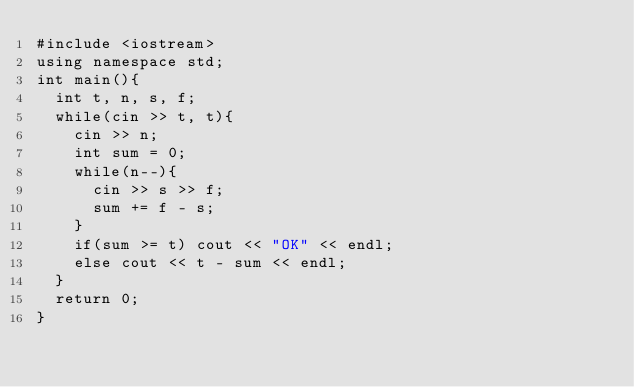Convert code to text. <code><loc_0><loc_0><loc_500><loc_500><_C++_>#include <iostream>
using namespace std;
int main(){
  int t, n, s, f;
  while(cin >> t, t){
    cin >> n;
    int sum = 0;
    while(n--){
      cin >> s >> f;
      sum += f - s;
    }
    if(sum >= t) cout << "OK" << endl;
    else cout << t - sum << endl;
  }
  return 0;
}</code> 